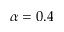<formula> <loc_0><loc_0><loc_500><loc_500>\alpha = 0 . 4</formula> 